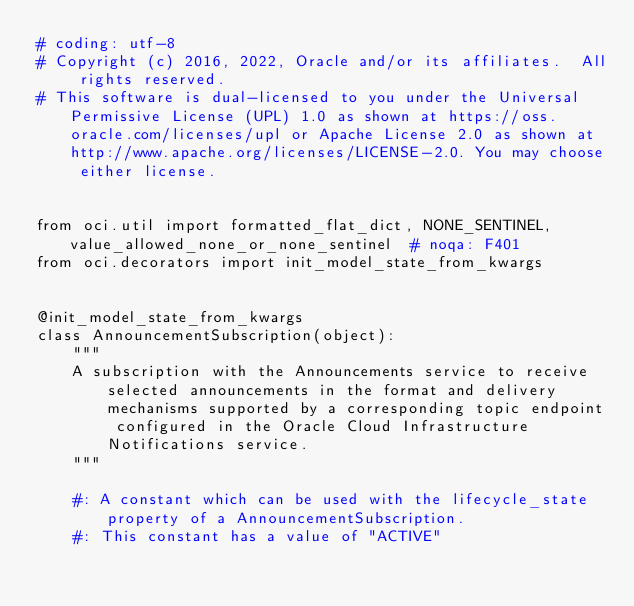<code> <loc_0><loc_0><loc_500><loc_500><_Python_># coding: utf-8
# Copyright (c) 2016, 2022, Oracle and/or its affiliates.  All rights reserved.
# This software is dual-licensed to you under the Universal Permissive License (UPL) 1.0 as shown at https://oss.oracle.com/licenses/upl or Apache License 2.0 as shown at http://www.apache.org/licenses/LICENSE-2.0. You may choose either license.


from oci.util import formatted_flat_dict, NONE_SENTINEL, value_allowed_none_or_none_sentinel  # noqa: F401
from oci.decorators import init_model_state_from_kwargs


@init_model_state_from_kwargs
class AnnouncementSubscription(object):
    """
    A subscription with the Announcements service to receive selected announcements in the format and delivery mechanisms supported by a corresponding topic endpoint configured in the Oracle Cloud Infrastructure Notifications service.
    """

    #: A constant which can be used with the lifecycle_state property of a AnnouncementSubscription.
    #: This constant has a value of "ACTIVE"</code> 